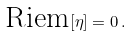<formula> <loc_0><loc_0><loc_500><loc_500>\text { Riem} [ \eta ] = 0 \, .</formula> 